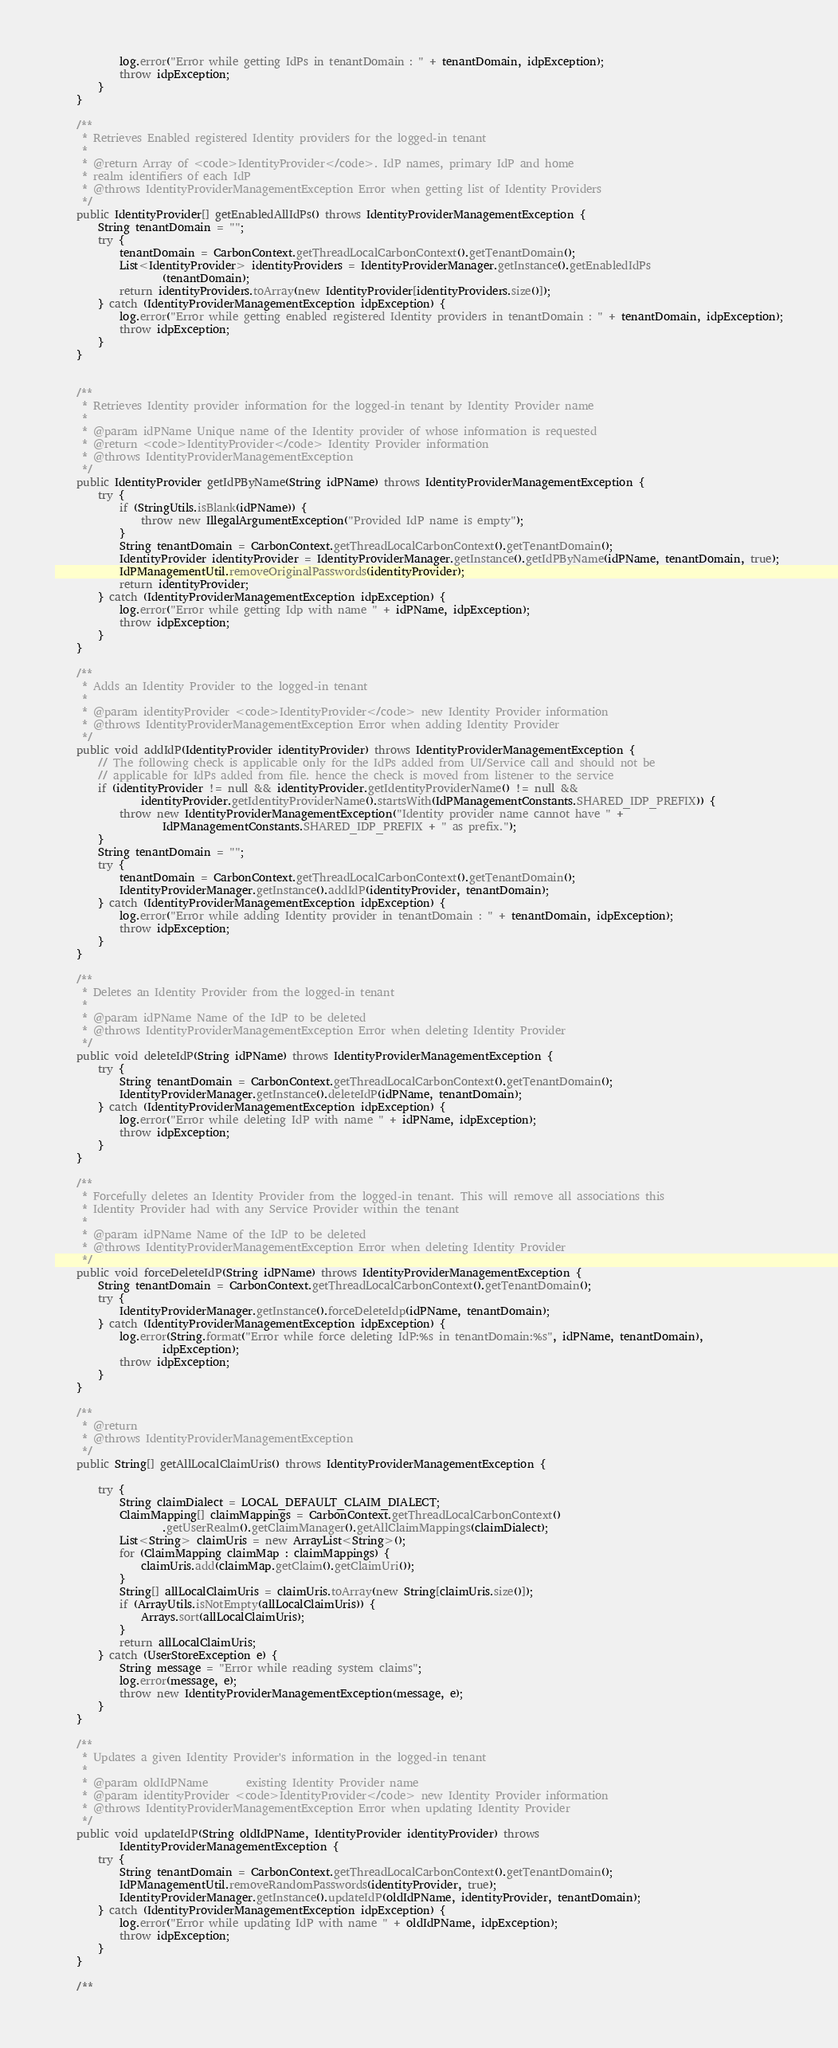<code> <loc_0><loc_0><loc_500><loc_500><_Java_>            log.error("Error while getting IdPs in tenantDomain : " + tenantDomain, idpException);
            throw idpException;
        }
    }
    
    /**
     * Retrieves Enabled registered Identity providers for the logged-in tenant
     *
     * @return Array of <code>IdentityProvider</code>. IdP names, primary IdP and home
     * realm identifiers of each IdP
     * @throws IdentityProviderManagementException Error when getting list of Identity Providers
     */
    public IdentityProvider[] getEnabledAllIdPs() throws IdentityProviderManagementException {
        String tenantDomain = "";
        try {
            tenantDomain = CarbonContext.getThreadLocalCarbonContext().getTenantDomain();
            List<IdentityProvider> identityProviders = IdentityProviderManager.getInstance().getEnabledIdPs
                    (tenantDomain);
            return identityProviders.toArray(new IdentityProvider[identityProviders.size()]);
        } catch (IdentityProviderManagementException idpException) {
            log.error("Error while getting enabled registered Identity providers in tenantDomain : " + tenantDomain, idpException);
            throw idpException;
        }
    }


    /**
     * Retrieves Identity provider information for the logged-in tenant by Identity Provider name
     *
     * @param idPName Unique name of the Identity provider of whose information is requested
     * @return <code>IdentityProvider</code> Identity Provider information
     * @throws IdentityProviderManagementException
     */
    public IdentityProvider getIdPByName(String idPName) throws IdentityProviderManagementException {
        try {
            if (StringUtils.isBlank(idPName)) {
                throw new IllegalArgumentException("Provided IdP name is empty");
            }
            String tenantDomain = CarbonContext.getThreadLocalCarbonContext().getTenantDomain();
            IdentityProvider identityProvider = IdentityProviderManager.getInstance().getIdPByName(idPName, tenantDomain, true);
            IdPManagementUtil.removeOriginalPasswords(identityProvider);
            return identityProvider;
        } catch (IdentityProviderManagementException idpException) {
            log.error("Error while getting Idp with name " + idPName, idpException);
            throw idpException;
        }
    }

    /**
     * Adds an Identity Provider to the logged-in tenant
     *
     * @param identityProvider <code>IdentityProvider</code> new Identity Provider information
     * @throws IdentityProviderManagementException Error when adding Identity Provider
     */
    public void addIdP(IdentityProvider identityProvider) throws IdentityProviderManagementException {
        // The following check is applicable only for the IdPs added from UI/Service call and should not be
        // applicable for IdPs added from file. hence the check is moved from listener to the service
        if (identityProvider != null && identityProvider.getIdentityProviderName() != null &&
                identityProvider.getIdentityProviderName().startsWith(IdPManagementConstants.SHARED_IDP_PREFIX)) {
            throw new IdentityProviderManagementException("Identity provider name cannot have " +
                    IdPManagementConstants.SHARED_IDP_PREFIX + " as prefix.");
        }
        String tenantDomain = "";
        try {
            tenantDomain = CarbonContext.getThreadLocalCarbonContext().getTenantDomain();
            IdentityProviderManager.getInstance().addIdP(identityProvider, tenantDomain);
        } catch (IdentityProviderManagementException idpException) {
            log.error("Error while adding Identity provider in tenantDomain : " + tenantDomain, idpException);
            throw idpException;
        }
    }

    /**
     * Deletes an Identity Provider from the logged-in tenant
     *
     * @param idPName Name of the IdP to be deleted
     * @throws IdentityProviderManagementException Error when deleting Identity Provider
     */
    public void deleteIdP(String idPName) throws IdentityProviderManagementException {
        try {
            String tenantDomain = CarbonContext.getThreadLocalCarbonContext().getTenantDomain();
            IdentityProviderManager.getInstance().deleteIdP(idPName, tenantDomain);
        } catch (IdentityProviderManagementException idpException) {
            log.error("Error while deleting IdP with name " + idPName, idpException);
            throw idpException;
        }
    }

    /**
     * Forcefully deletes an Identity Provider from the logged-in tenant. This will remove all associations this
     * Identity Provider had with any Service Provider within the tenant
     *
     * @param idPName Name of the IdP to be deleted
     * @throws IdentityProviderManagementException Error when deleting Identity Provider
     */
    public void forceDeleteIdP(String idPName) throws IdentityProviderManagementException {
        String tenantDomain = CarbonContext.getThreadLocalCarbonContext().getTenantDomain();
        try {
            IdentityProviderManager.getInstance().forceDeleteIdp(idPName, tenantDomain);
        } catch (IdentityProviderManagementException idpException) {
            log.error(String.format("Error while force deleting IdP:%s in tenantDomain:%s", idPName, tenantDomain),
                    idpException);
            throw idpException;
        }
    }

    /**
     * @return
     * @throws IdentityProviderManagementException
     */
    public String[] getAllLocalClaimUris() throws IdentityProviderManagementException {

        try {
            String claimDialect = LOCAL_DEFAULT_CLAIM_DIALECT;
            ClaimMapping[] claimMappings = CarbonContext.getThreadLocalCarbonContext()
                    .getUserRealm().getClaimManager().getAllClaimMappings(claimDialect);
            List<String> claimUris = new ArrayList<String>();
            for (ClaimMapping claimMap : claimMappings) {
                claimUris.add(claimMap.getClaim().getClaimUri());
            }
            String[] allLocalClaimUris = claimUris.toArray(new String[claimUris.size()]);
            if (ArrayUtils.isNotEmpty(allLocalClaimUris)) {
                Arrays.sort(allLocalClaimUris);
            }
            return allLocalClaimUris;
        } catch (UserStoreException e) {
            String message = "Error while reading system claims";
            log.error(message, e);
            throw new IdentityProviderManagementException(message, e);
        }
    }

    /**
     * Updates a given Identity Provider's information in the logged-in tenant
     *
     * @param oldIdPName       existing Identity Provider name
     * @param identityProvider <code>IdentityProvider</code> new Identity Provider information
     * @throws IdentityProviderManagementException Error when updating Identity Provider
     */
    public void updateIdP(String oldIdPName, IdentityProvider identityProvider) throws
            IdentityProviderManagementException {
        try {
            String tenantDomain = CarbonContext.getThreadLocalCarbonContext().getTenantDomain();
            IdPManagementUtil.removeRandomPasswords(identityProvider, true);
            IdentityProviderManager.getInstance().updateIdP(oldIdPName, identityProvider, tenantDomain);
        } catch (IdentityProviderManagementException idpException) {
            log.error("Error while updating IdP with name " + oldIdPName, idpException);
            throw idpException;
        }
    }

    /**</code> 